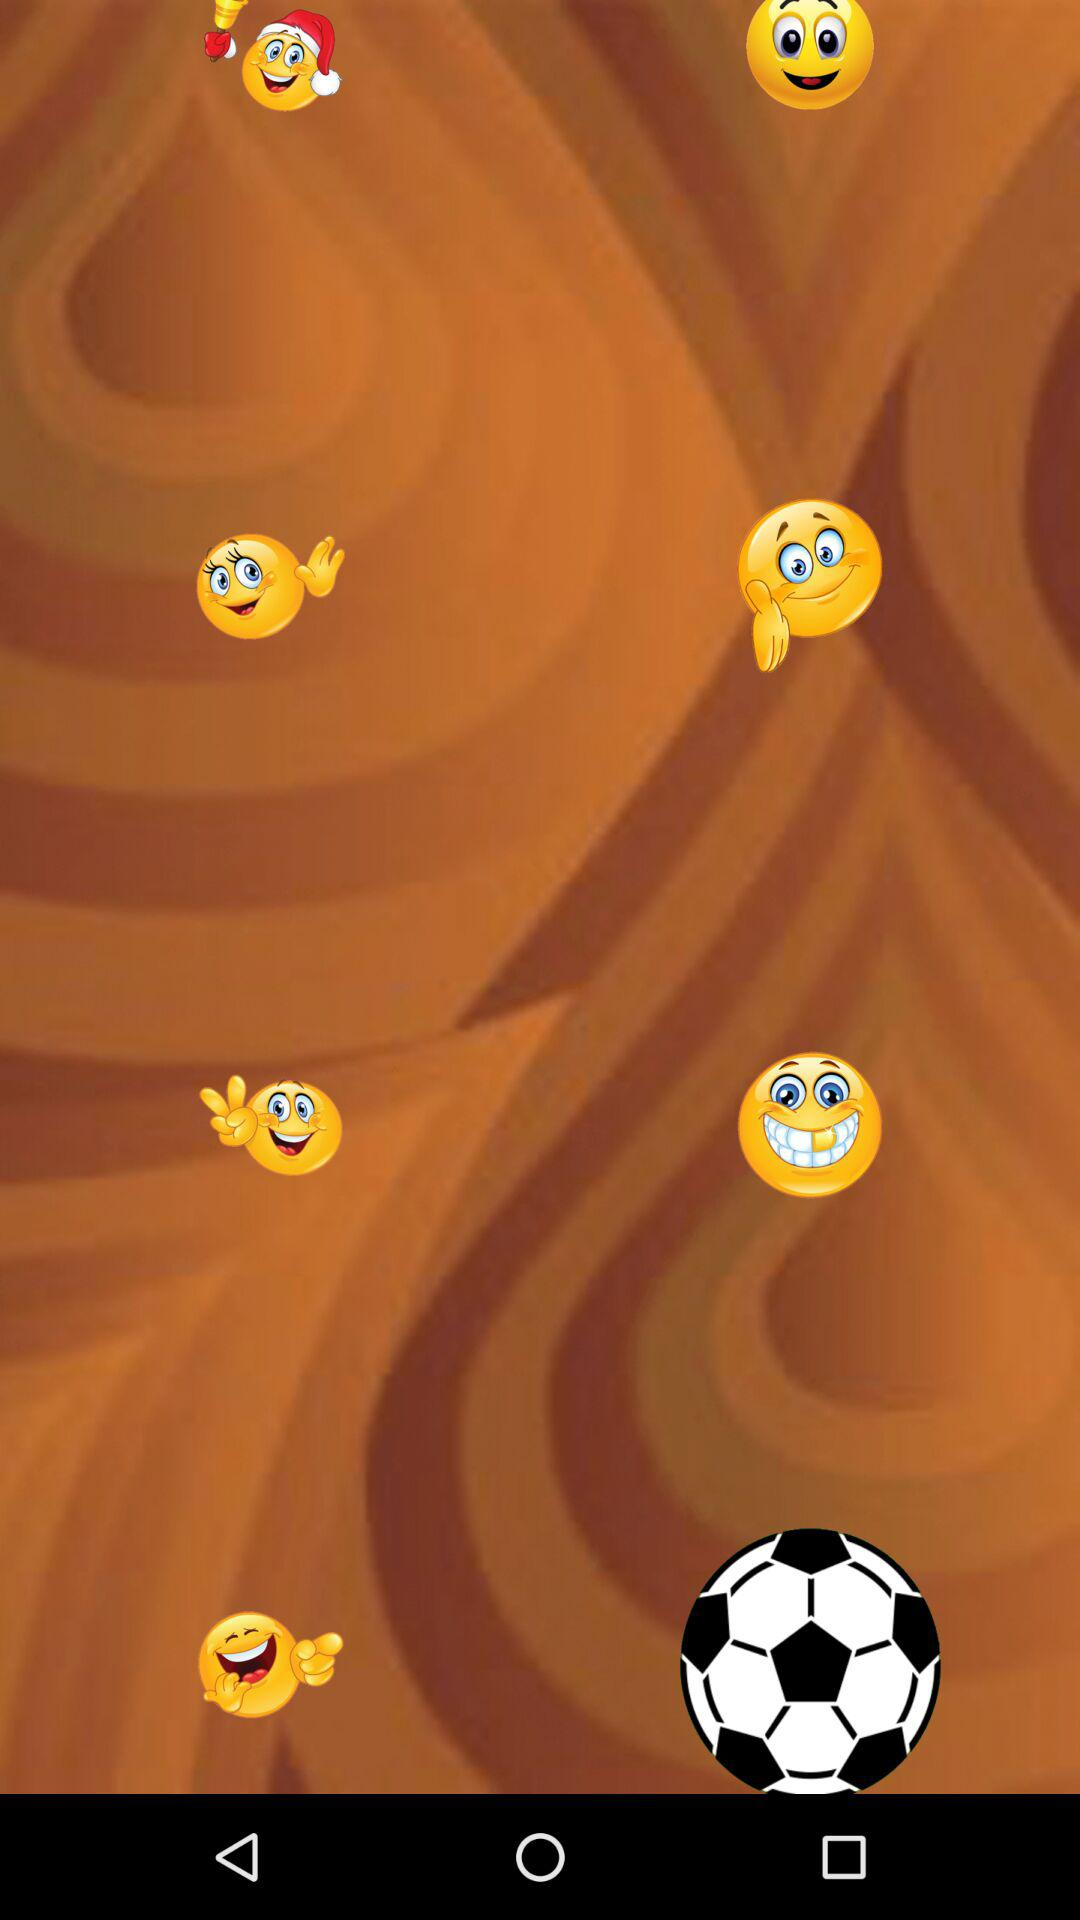How many smiley faces are wearing a santa hat?
Answer the question using a single word or phrase. 1 